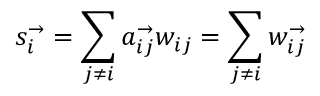<formula> <loc_0><loc_0><loc_500><loc_500>s _ { i } ^ { \rightarrow } = \sum _ { j \neq i } a _ { i j } ^ { \rightarrow } w _ { i j } = \sum _ { j \neq i } w _ { i j } ^ { \rightarrow }</formula> 